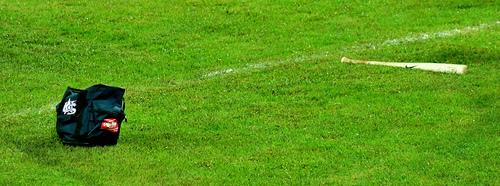Is there an active practice session?
Short answer required. No. Is the possibly a baseball field?
Keep it brief. Yes. Where is the baseball bat?
Be succinct. Ground. 